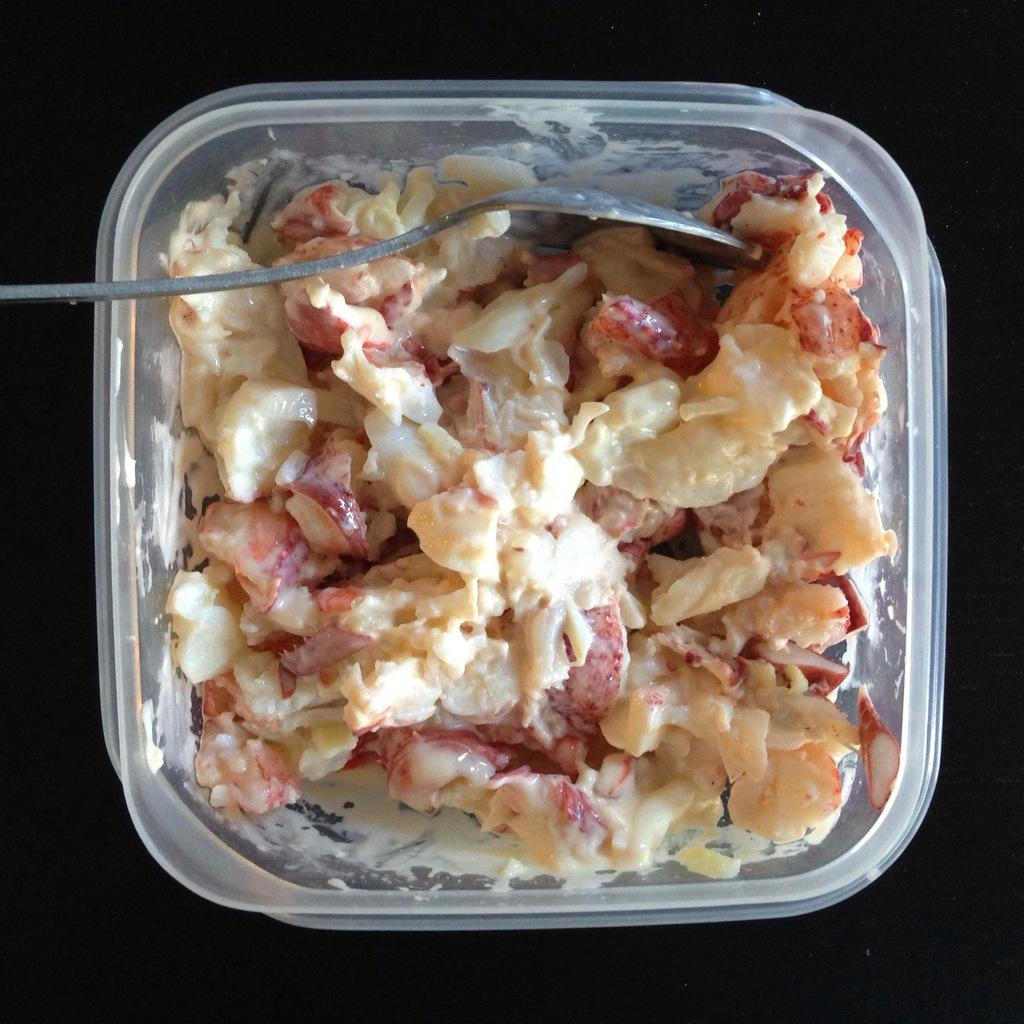What is the color of the box in the image? The box in the image is white. What is inside the box? The box contains food. What utensil is visible in the image? There is a spoon visible in the image. What color is the background of the image? The background of the image is black. How does the person in the image draw attention to their chin? There is no person present in the image, and therefore no chin or action to draw attention to it. 